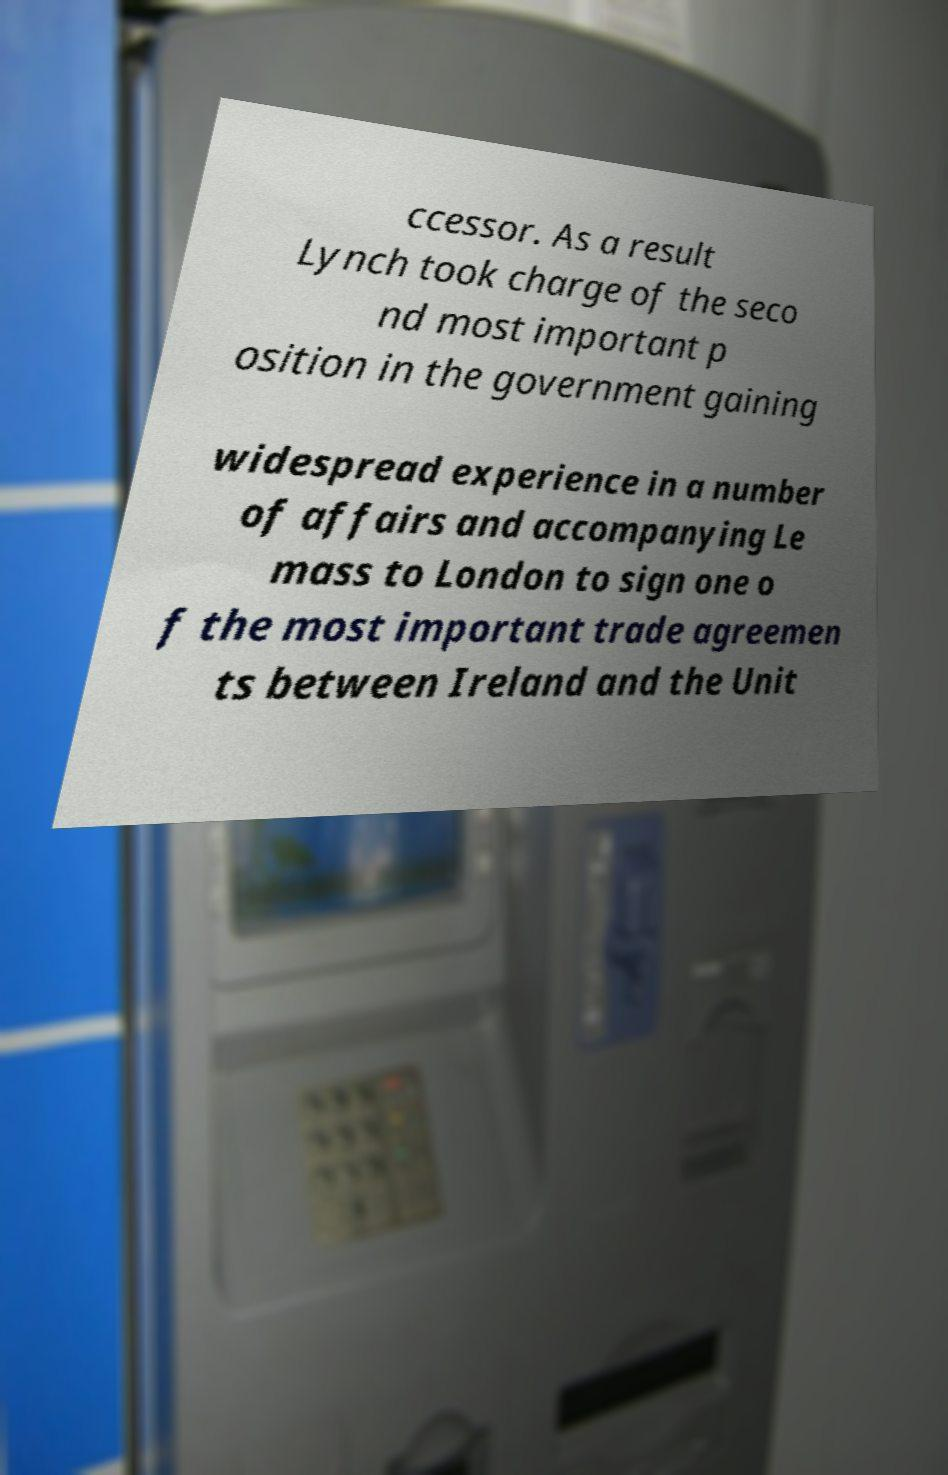Can you read and provide the text displayed in the image?This photo seems to have some interesting text. Can you extract and type it out for me? ccessor. As a result Lynch took charge of the seco nd most important p osition in the government gaining widespread experience in a number of affairs and accompanying Le mass to London to sign one o f the most important trade agreemen ts between Ireland and the Unit 